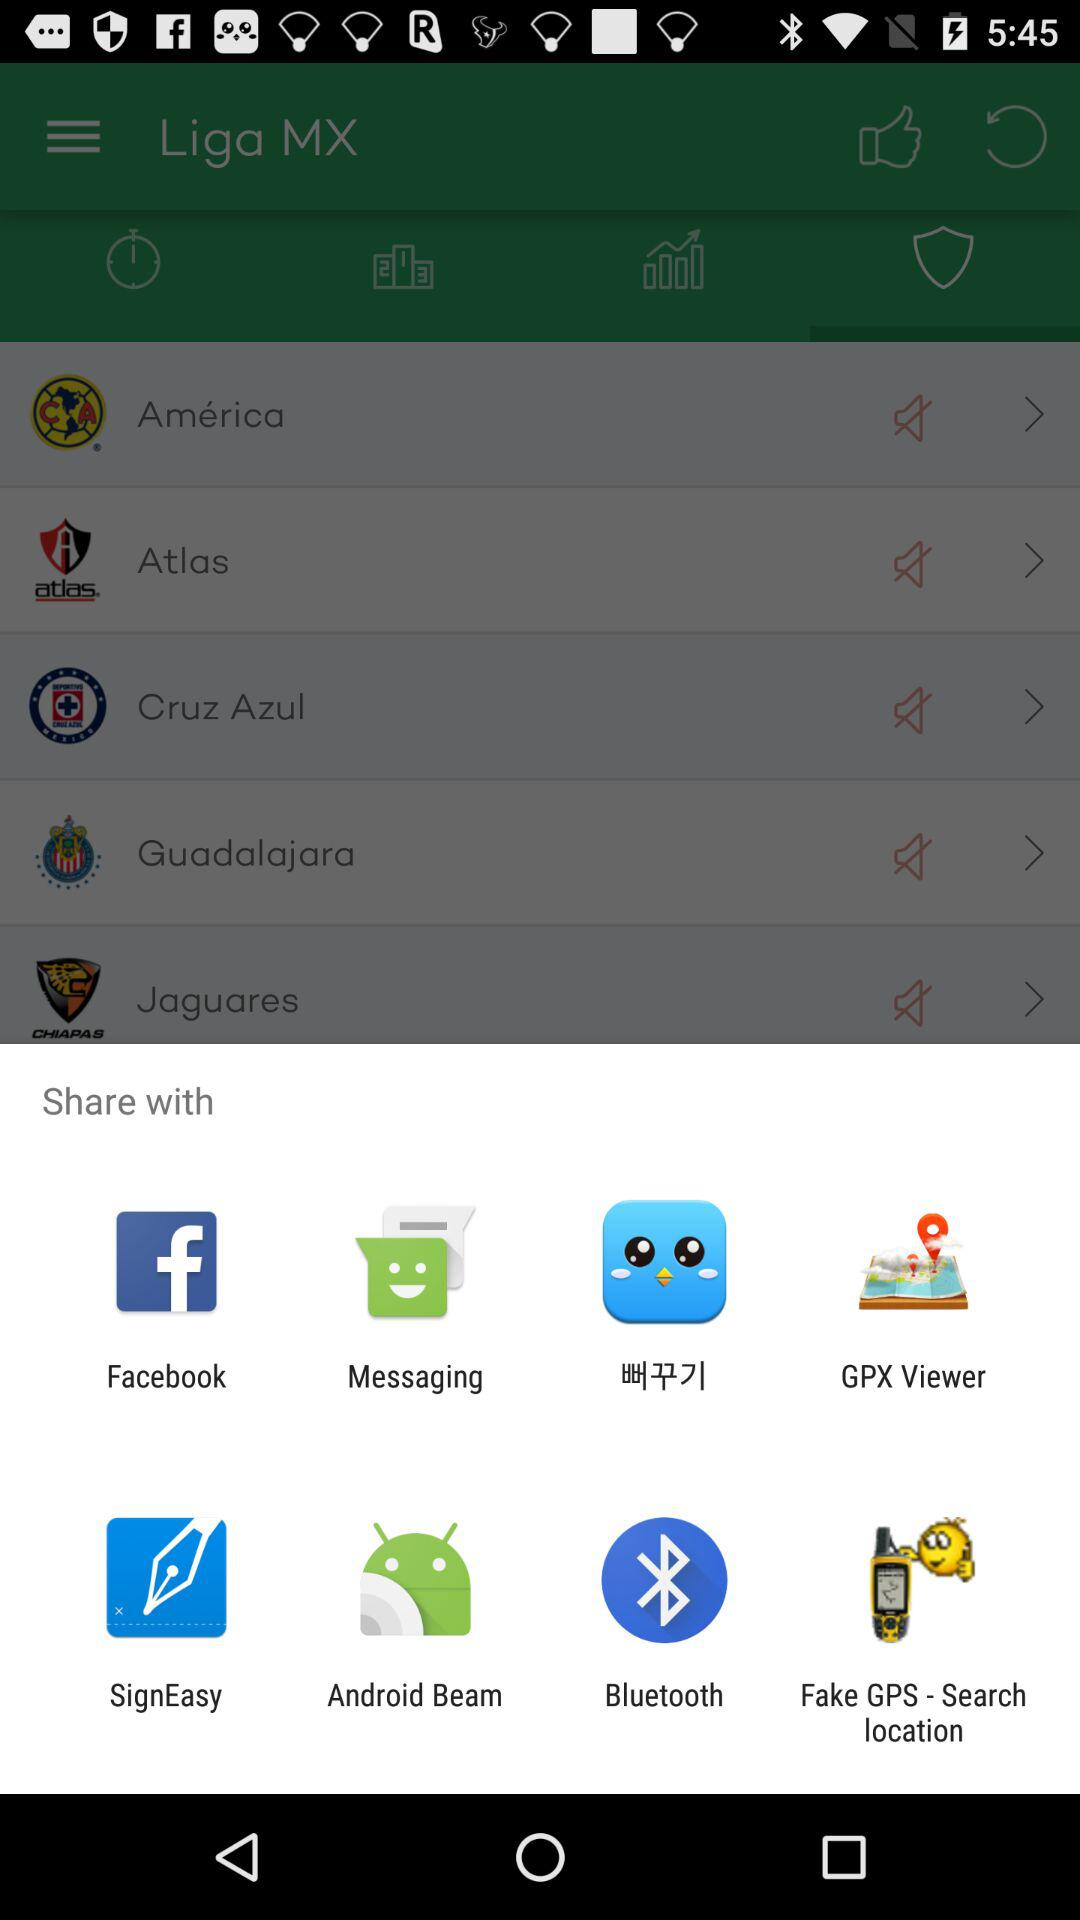How many likes does the "Liga MX" application have?
When the provided information is insufficient, respond with <no answer>. <no answer> 